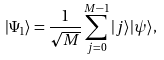Convert formula to latex. <formula><loc_0><loc_0><loc_500><loc_500>| \Psi _ { 1 } \rangle = \frac { 1 } { \sqrt { M } } \sum _ { j = 0 } ^ { M - 1 } | j \rangle | \psi \rangle ,</formula> 